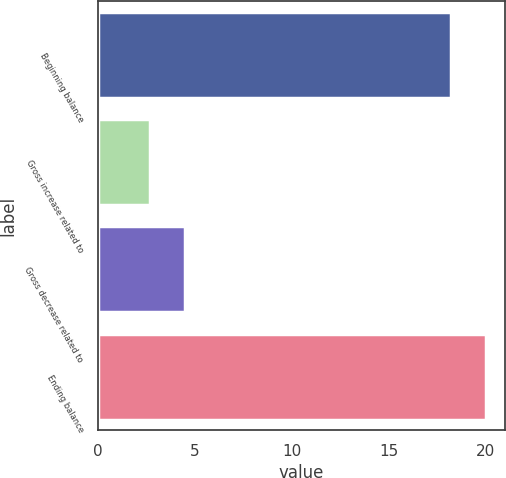<chart> <loc_0><loc_0><loc_500><loc_500><bar_chart><fcel>Beginning balance<fcel>Gross increase related to<fcel>Gross decrease related to<fcel>Ending balance<nl><fcel>18.2<fcel>2.7<fcel>4.51<fcel>20.01<nl></chart> 